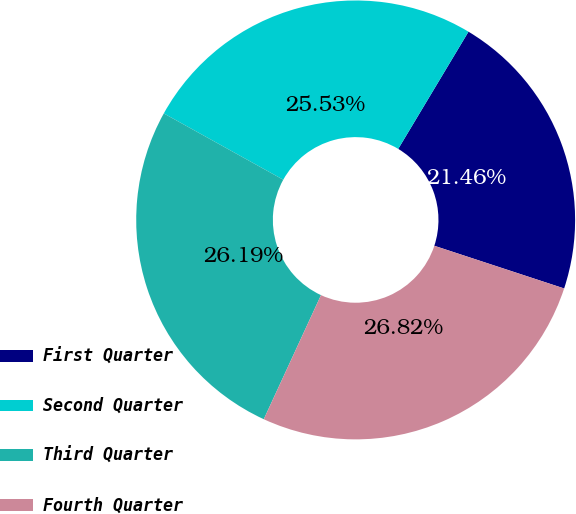Convert chart. <chart><loc_0><loc_0><loc_500><loc_500><pie_chart><fcel>First Quarter<fcel>Second Quarter<fcel>Third Quarter<fcel>Fourth Quarter<nl><fcel>21.46%<fcel>25.53%<fcel>26.19%<fcel>26.82%<nl></chart> 